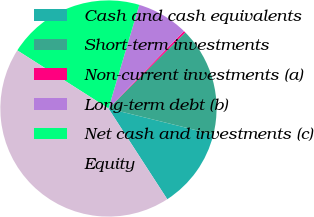<chart> <loc_0><loc_0><loc_500><loc_500><pie_chart><fcel>Cash and cash equivalents<fcel>Short-term investments<fcel>Non-current investments (a)<fcel>Long-term debt (b)<fcel>Net cash and investments (c)<fcel>Equity<nl><fcel>11.99%<fcel>16.28%<fcel>0.28%<fcel>7.7%<fcel>20.57%<fcel>43.18%<nl></chart> 